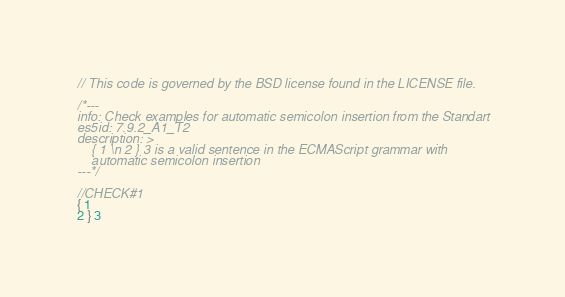Convert code to text. <code><loc_0><loc_0><loc_500><loc_500><_JavaScript_>// This code is governed by the BSD license found in the LICENSE file.

/*---
info: Check examples for automatic semicolon insertion from the Standart
es5id: 7.9.2_A1_T2
description: >
    { 1 \n 2 } 3 is a valid sentence in the ECMAScript grammar with
    automatic semicolon insertion
---*/

//CHECK#1
{ 1
2 } 3
</code> 